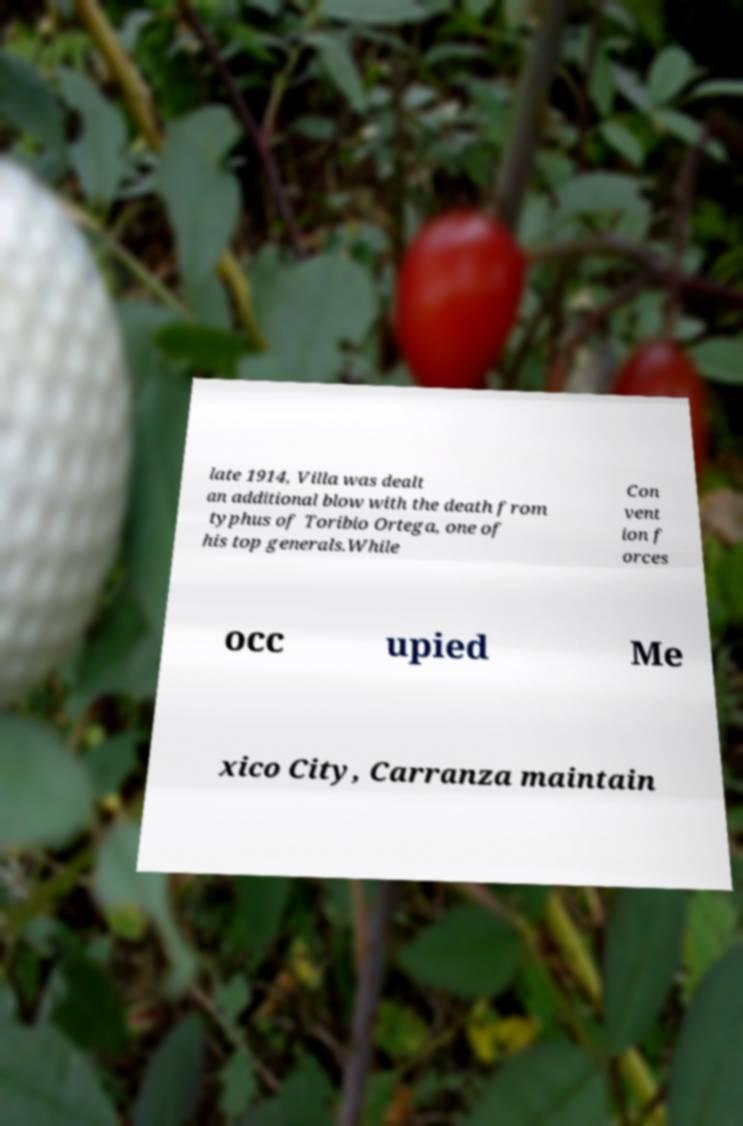Could you assist in decoding the text presented in this image and type it out clearly? late 1914, Villa was dealt an additional blow with the death from typhus of Toribio Ortega, one of his top generals.While Con vent ion f orces occ upied Me xico City, Carranza maintain 